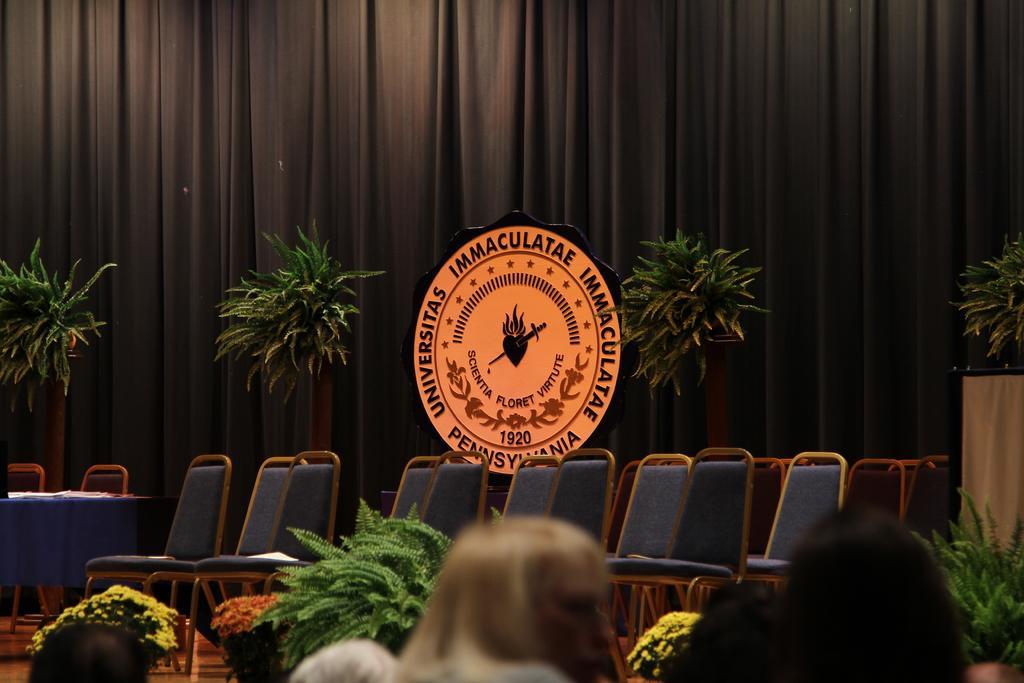Please provide a concise description of this image. In this picture there are some chairs on the stage. Behind there is a orange logo and some plants. In the background there is a brown color curtain. 